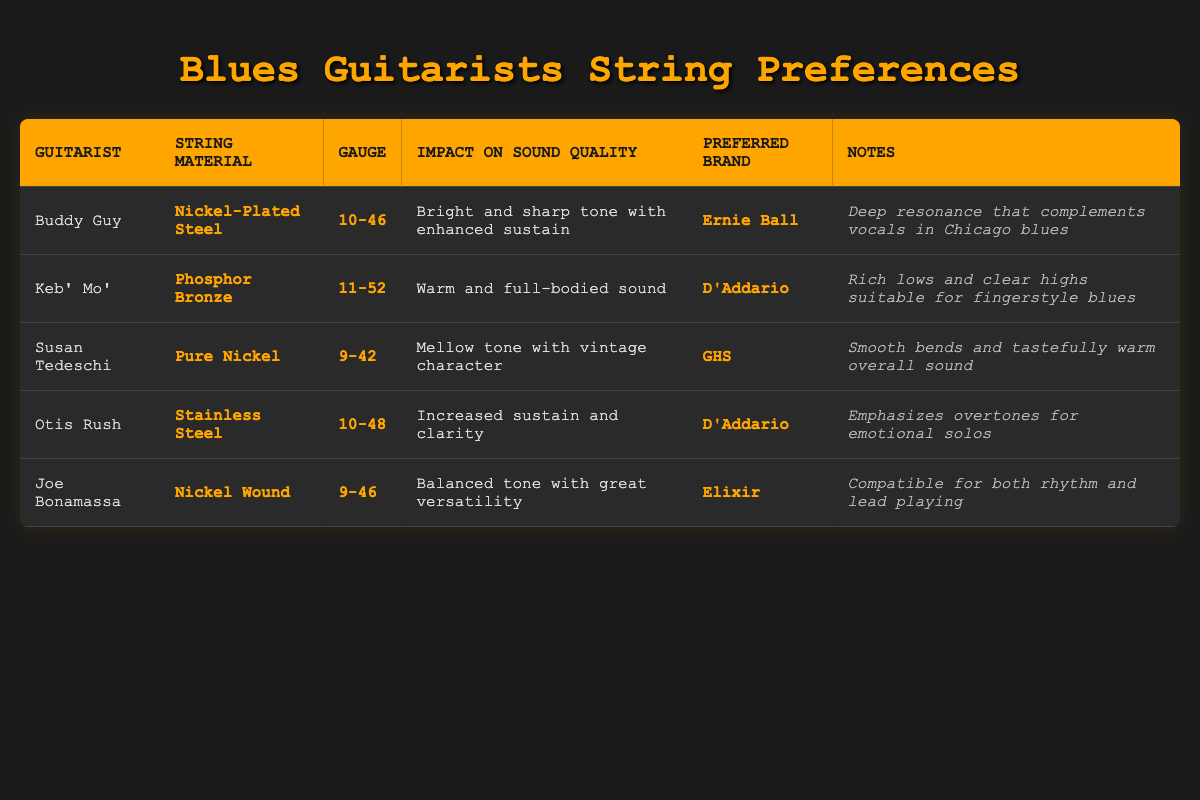What string material does Buddy Guy prefer? According to the table, Buddy Guy prefers "Nickel-Plated Steel" for his guitar strings.
Answer: Nickel-Plated Steel What is the impact on sound quality when using Keb' Mo's preferred string material? The table indicates that Keb' Mo's preferred string material, "Phosphor Bronze," provides a "Warm and full-bodied sound."
Answer: Warm and full-bodied sound Which guitarist uses a 9-42 gauge? In the table, Susan Tedeschi is listed with a gauge of "9-42."
Answer: Susan Tedeschi Is Joe Bonamassa's preferred brand the same as Keb' Mo's preferred brand? The table shows Joe Bonamassa's preferred brand is "Elixir," while Keb' Mo's is "D'Addario." Therefore, the answer is no.
Answer: No Among the listed guitarists, who has the greatest gauge value? By examining the table, the highest gauge listed is "11-52," which belongs to Keb' Mo'.
Answer: Keb' Mo' What is the average gauge of the strings used by all the guitarists? To find the average gauge, convert each gauge notation (10-46, 11-52, etc.) to a single numeric value. Then, calculate the average: (46+52+42+48+46)/5 = 46.8. Hence, the average gauge is approximately 46.8.
Answer: Approximately 46.8 Does Susan Tedeschi's string choice provide clarity in sound? Based on the table, Susan Tedeschi's strings offer a "Mellow tone with vintage character," which does not specifically mention clarity. Therefore, the answer is no.
Answer: No What describes the sound impact of Otis Rush’s preferred strings? According to the table, Otis Rush's strings lead to "Increased sustain and clarity," thus enhancing the expressiveness of his playing style.
Answer: Increased sustain and clarity Which guitarist’s string choice emphasizes overtones? The table mentions that Otis Rush’s string choice enhances overtones, particularly for emotional solos.
Answer: Otis Rush 